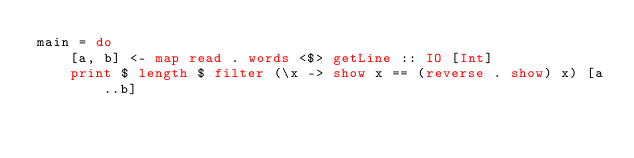Convert code to text. <code><loc_0><loc_0><loc_500><loc_500><_Haskell_>main = do
    [a, b] <- map read . words <$> getLine :: IO [Int]
    print $ length $ filter (\x -> show x == (reverse . show) x) [a..b]
</code> 